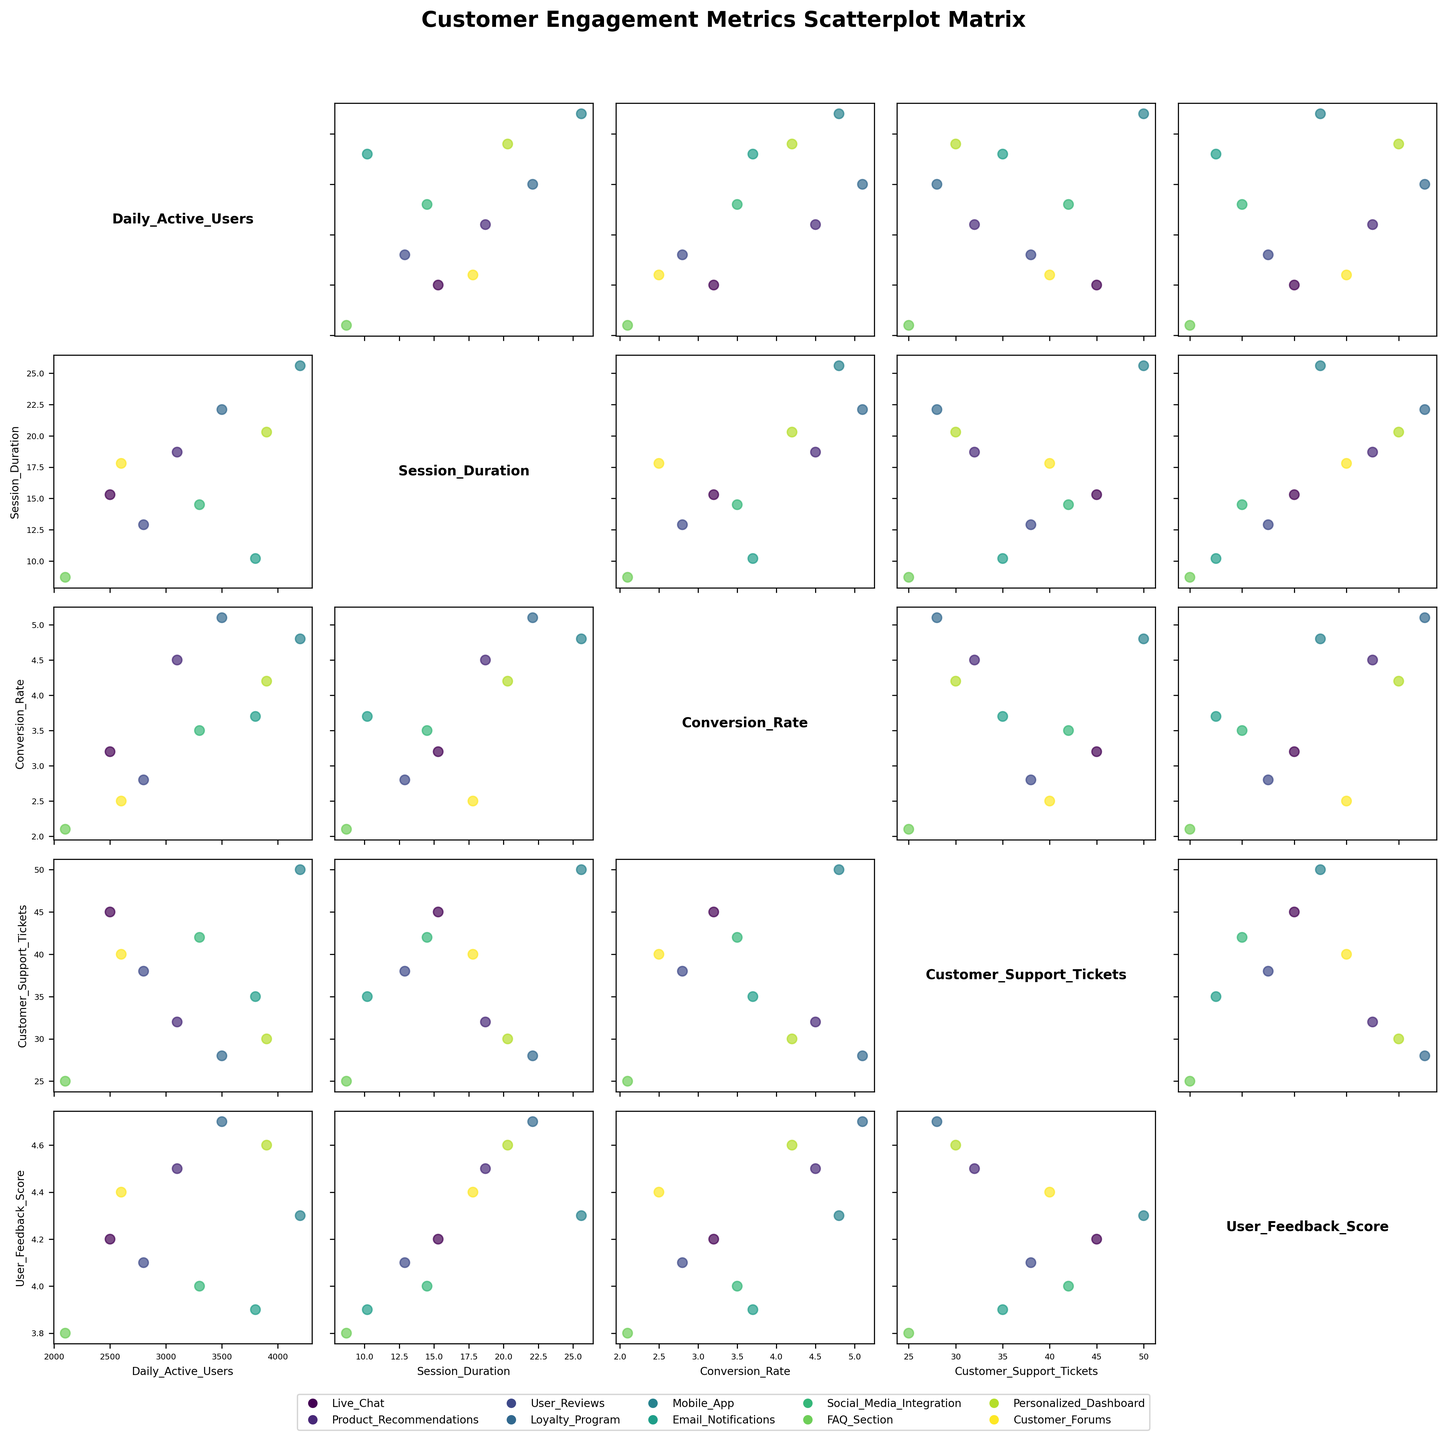What's the title of the figure? The title of the figure is typically at the top of the plot and gives a summary of what the plot represents. In this case, it states, "Customer Engagement Metrics Scatterplot Matrix".
Answer: Customer Engagement Metrics Scatterplot Matrix Which feature has the highest Daily Active Users? By looking at the scatterplots, particularly the ones where "Daily_Active_Users" is plotted, we notice that the Mobile_App has the highest number of daily active users among all the other features.
Answer: Mobile_App How many features are compared in the scatterplots? Count the number of different features in the legend or diagonal cells of the scatterplot matrix. There are 10 features listed, namely Live_Chat, Product_Recommendations, User_Reviews, Loyalty_Program, Mobile_App, Email_Notifications, Social_Media_Integration, FAQ_Section, Personalized_Dashboard, and Customer_Forums.
Answer: 10 Is there any feature with a high Conversion Rate but a lower User Feedback Score? Cross-reference scatter plots involving Conversion Rate and User Feedback Score. Email_Notifications has a relatively high Conversion Rate but a lower User Feedback Score compared to other features like Loyalty_Program.
Answer: Email_Notifications Which feature tends to have the longest Session Duration? Check the scatterplots and see which feature reaches the highest point on the Session Duration axis. Mobile_App exhibits the longest session duration among all features.
Answer: Mobile_App Do features with higher Daily Active Users generally have longer session durations? Observe the scatterplot between "Daily_Active_Users" and "Session_Duration". Features like Mobile_App and Personalized_Dashboard both have high Daily Active Users and relatively long session durations, suggesting a positive relationship.
Answer: Yes How are the Customer Support Tickets related to the User Feedback Score for the different features? By observing the scatter plot between "Customer_Support_Tickets" and "User_Feedback_Score", there appears to be a negative correlation. For example, FAQ_Section has fewer support tickets and a slightly lower feedback score, while Mobile_App has more support tickets but a higher feedback score.
Answer: Generally negative correlation Which feature has the highest Customer Support Tickets? Looking at the scatter plots involving "Customer_Support_Tickets" on the y-axis will show the feature with the highest data points. Mobile_App has the highest number of customer support tickets among all features.
Answer: Mobile_App Do features with higher conversion rates typically receive higher user feedback scores? Compare the scatter plots involving "Conversion_Rate" and "User_Feedback_Score". Features like Loyalty_Program and Product_Recommendations both have higher conversion rates and high user feedback scores, indicating a positive correlation.
Answer: Yes Which feature has the lowest session duration? Check the scatterplots where "Session_Duration" is involved. FAQ_Section has the lowest session duration among all the features.
Answer: FAQ_Section 